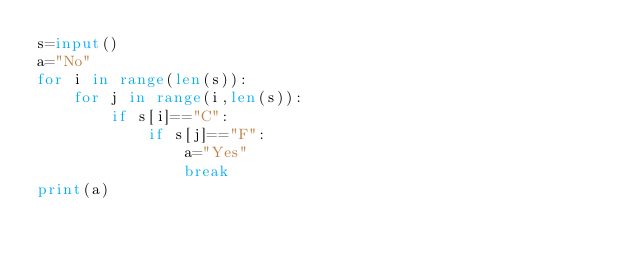Convert code to text. <code><loc_0><loc_0><loc_500><loc_500><_Python_>s=input()
a="No"
for i in range(len(s)):
    for j in range(i,len(s)):
        if s[i]=="C":
            if s[j]=="F":
                a="Yes"
                break
print(a)</code> 